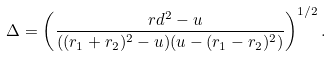Convert formula to latex. <formula><loc_0><loc_0><loc_500><loc_500>\Delta = \left ( \frac { \ r d ^ { 2 } - u } { ( ( r _ { 1 } + r _ { 2 } ) ^ { 2 } - u ) ( u - ( r _ { 1 } - r _ { 2 } ) ^ { 2 } ) } \right ) ^ { 1 / 2 } .</formula> 